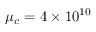<formula> <loc_0><loc_0><loc_500><loc_500>\mu _ { c } = 4 \times 1 0 ^ { 1 0 }</formula> 